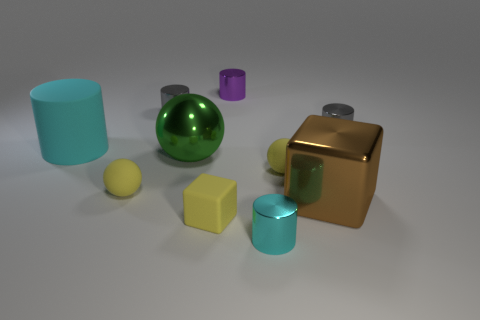Subtract all purple cylinders. How many cylinders are left? 4 Subtract all small purple cylinders. How many cylinders are left? 4 Subtract all blue cylinders. Subtract all brown blocks. How many cylinders are left? 5 Subtract all balls. How many objects are left? 7 Subtract all big cyan cylinders. Subtract all cyan metallic cylinders. How many objects are left? 8 Add 8 big cyan matte things. How many big cyan matte things are left? 9 Add 2 cylinders. How many cylinders exist? 7 Subtract 1 gray cylinders. How many objects are left? 9 